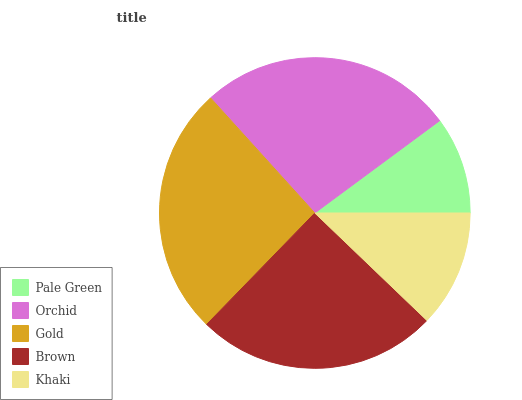Is Pale Green the minimum?
Answer yes or no. Yes. Is Orchid the maximum?
Answer yes or no. Yes. Is Gold the minimum?
Answer yes or no. No. Is Gold the maximum?
Answer yes or no. No. Is Orchid greater than Gold?
Answer yes or no. Yes. Is Gold less than Orchid?
Answer yes or no. Yes. Is Gold greater than Orchid?
Answer yes or no. No. Is Orchid less than Gold?
Answer yes or no. No. Is Brown the high median?
Answer yes or no. Yes. Is Brown the low median?
Answer yes or no. Yes. Is Gold the high median?
Answer yes or no. No. Is Khaki the low median?
Answer yes or no. No. 